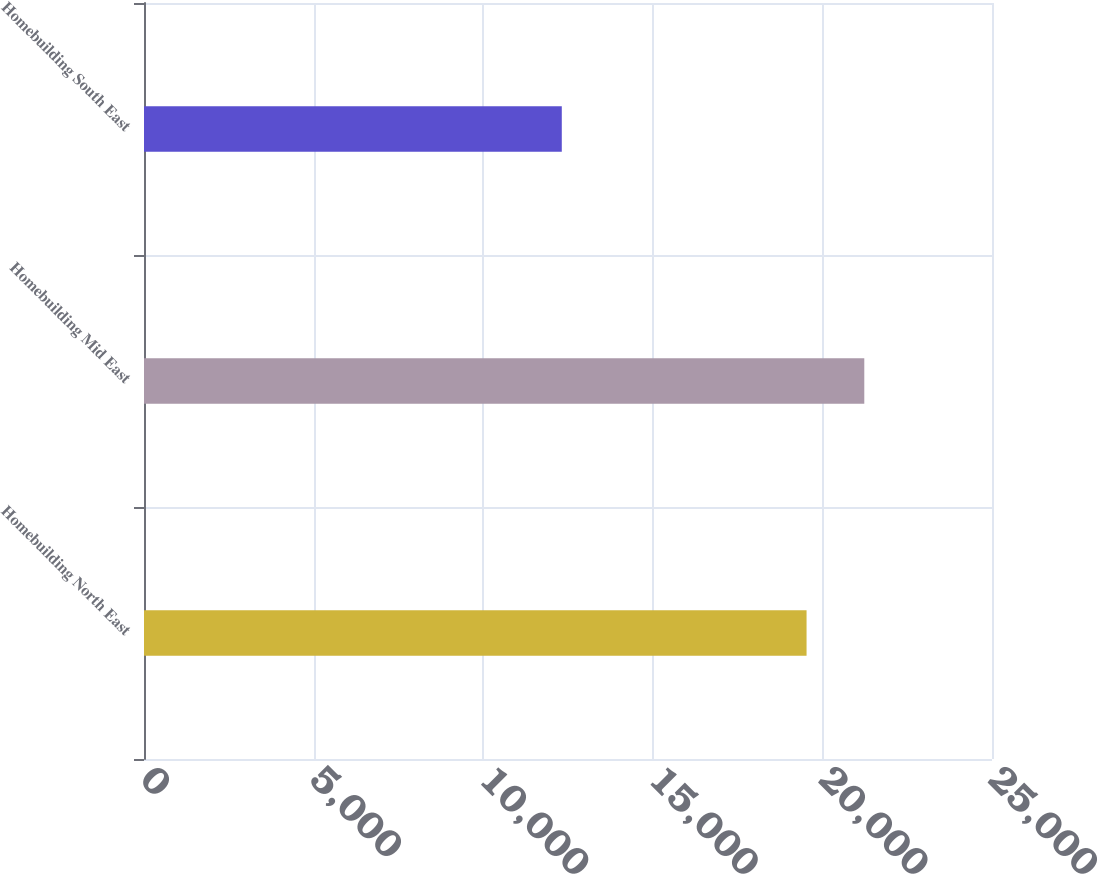Convert chart to OTSL. <chart><loc_0><loc_0><loc_500><loc_500><bar_chart><fcel>Homebuilding North East<fcel>Homebuilding Mid East<fcel>Homebuilding South East<nl><fcel>19533<fcel>21235<fcel>12317<nl></chart> 